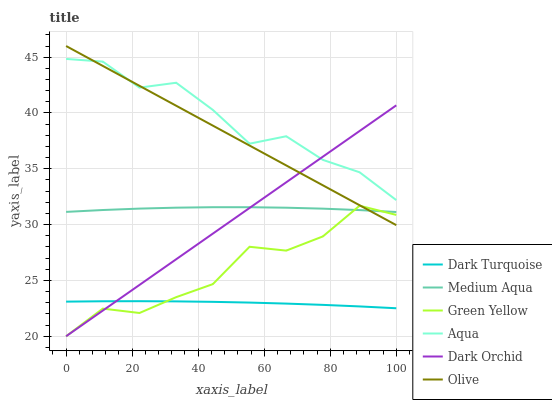Does Dark Turquoise have the minimum area under the curve?
Answer yes or no. Yes. Does Aqua have the maximum area under the curve?
Answer yes or no. Yes. Does Dark Orchid have the minimum area under the curve?
Answer yes or no. No. Does Dark Orchid have the maximum area under the curve?
Answer yes or no. No. Is Dark Orchid the smoothest?
Answer yes or no. Yes. Is Green Yellow the roughest?
Answer yes or no. Yes. Is Aqua the smoothest?
Answer yes or no. No. Is Aqua the roughest?
Answer yes or no. No. Does Dark Orchid have the lowest value?
Answer yes or no. Yes. Does Aqua have the lowest value?
Answer yes or no. No. Does Olive have the highest value?
Answer yes or no. Yes. Does Aqua have the highest value?
Answer yes or no. No. Is Dark Turquoise less than Medium Aqua?
Answer yes or no. Yes. Is Olive greater than Dark Turquoise?
Answer yes or no. Yes. Does Green Yellow intersect Dark Turquoise?
Answer yes or no. Yes. Is Green Yellow less than Dark Turquoise?
Answer yes or no. No. Is Green Yellow greater than Dark Turquoise?
Answer yes or no. No. Does Dark Turquoise intersect Medium Aqua?
Answer yes or no. No. 